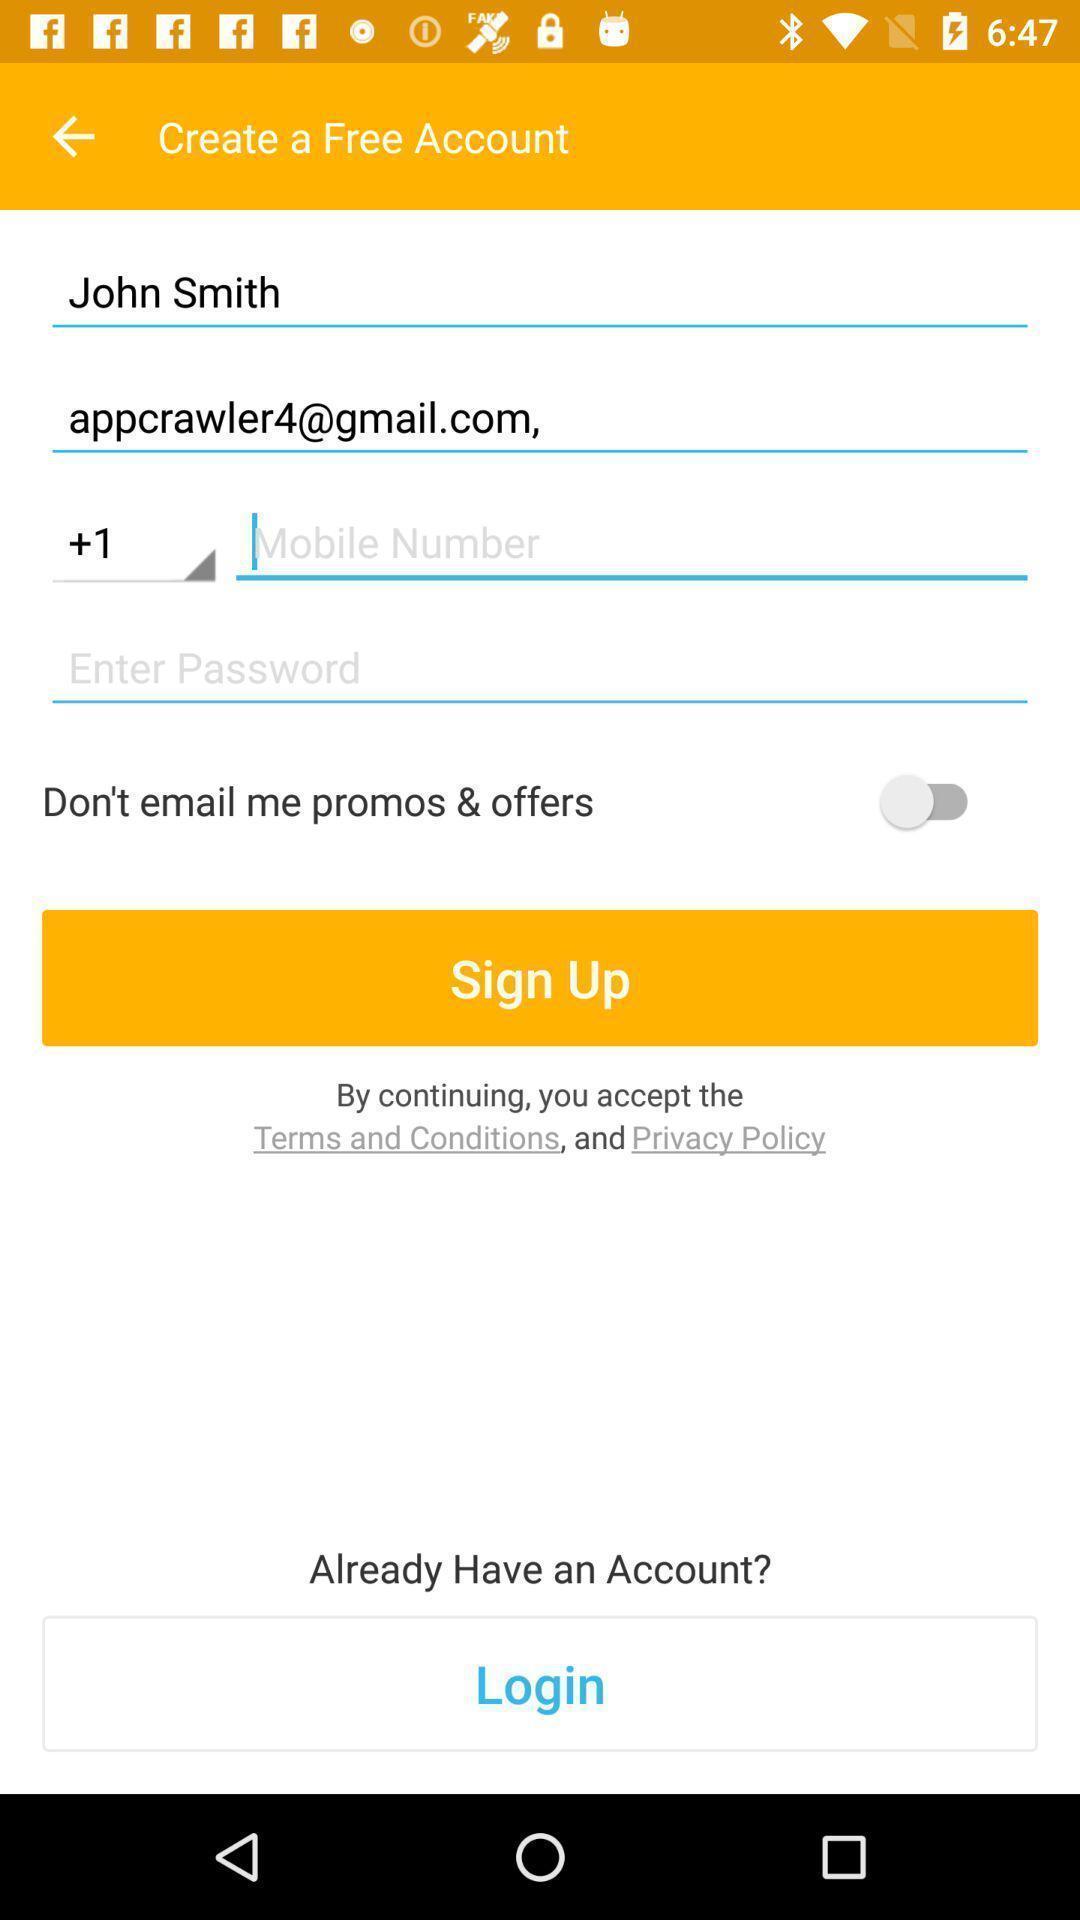Describe the content in this image. Sign up page for an app. 